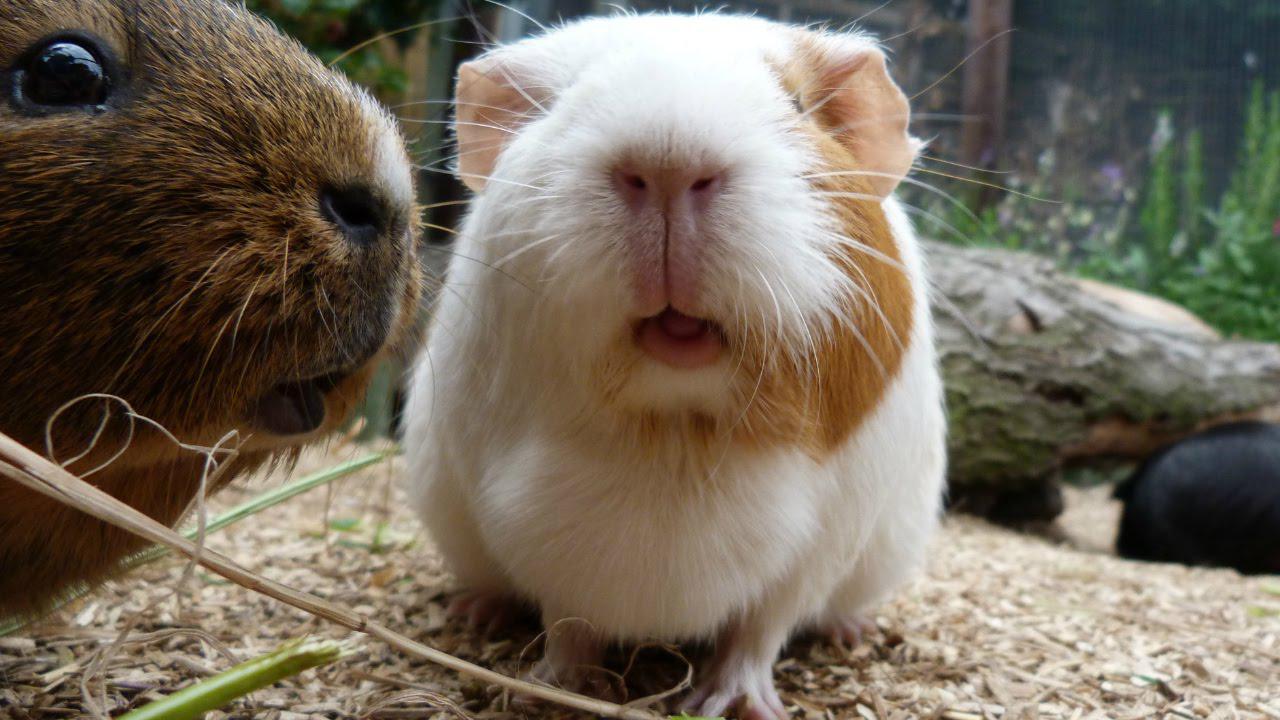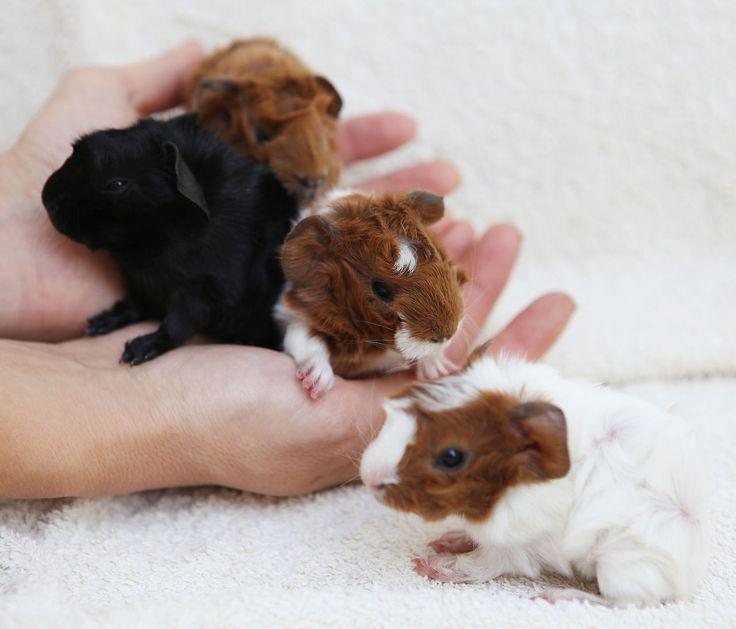The first image is the image on the left, the second image is the image on the right. Assess this claim about the two images: "Three hamsters are held in human hands in one image.". Correct or not? Answer yes or no. Yes. The first image is the image on the left, the second image is the image on the right. Considering the images on both sides, is "In one image, three gerbils are being held in one or more human hands that have the palm up and fingers extended." valid? Answer yes or no. Yes. 